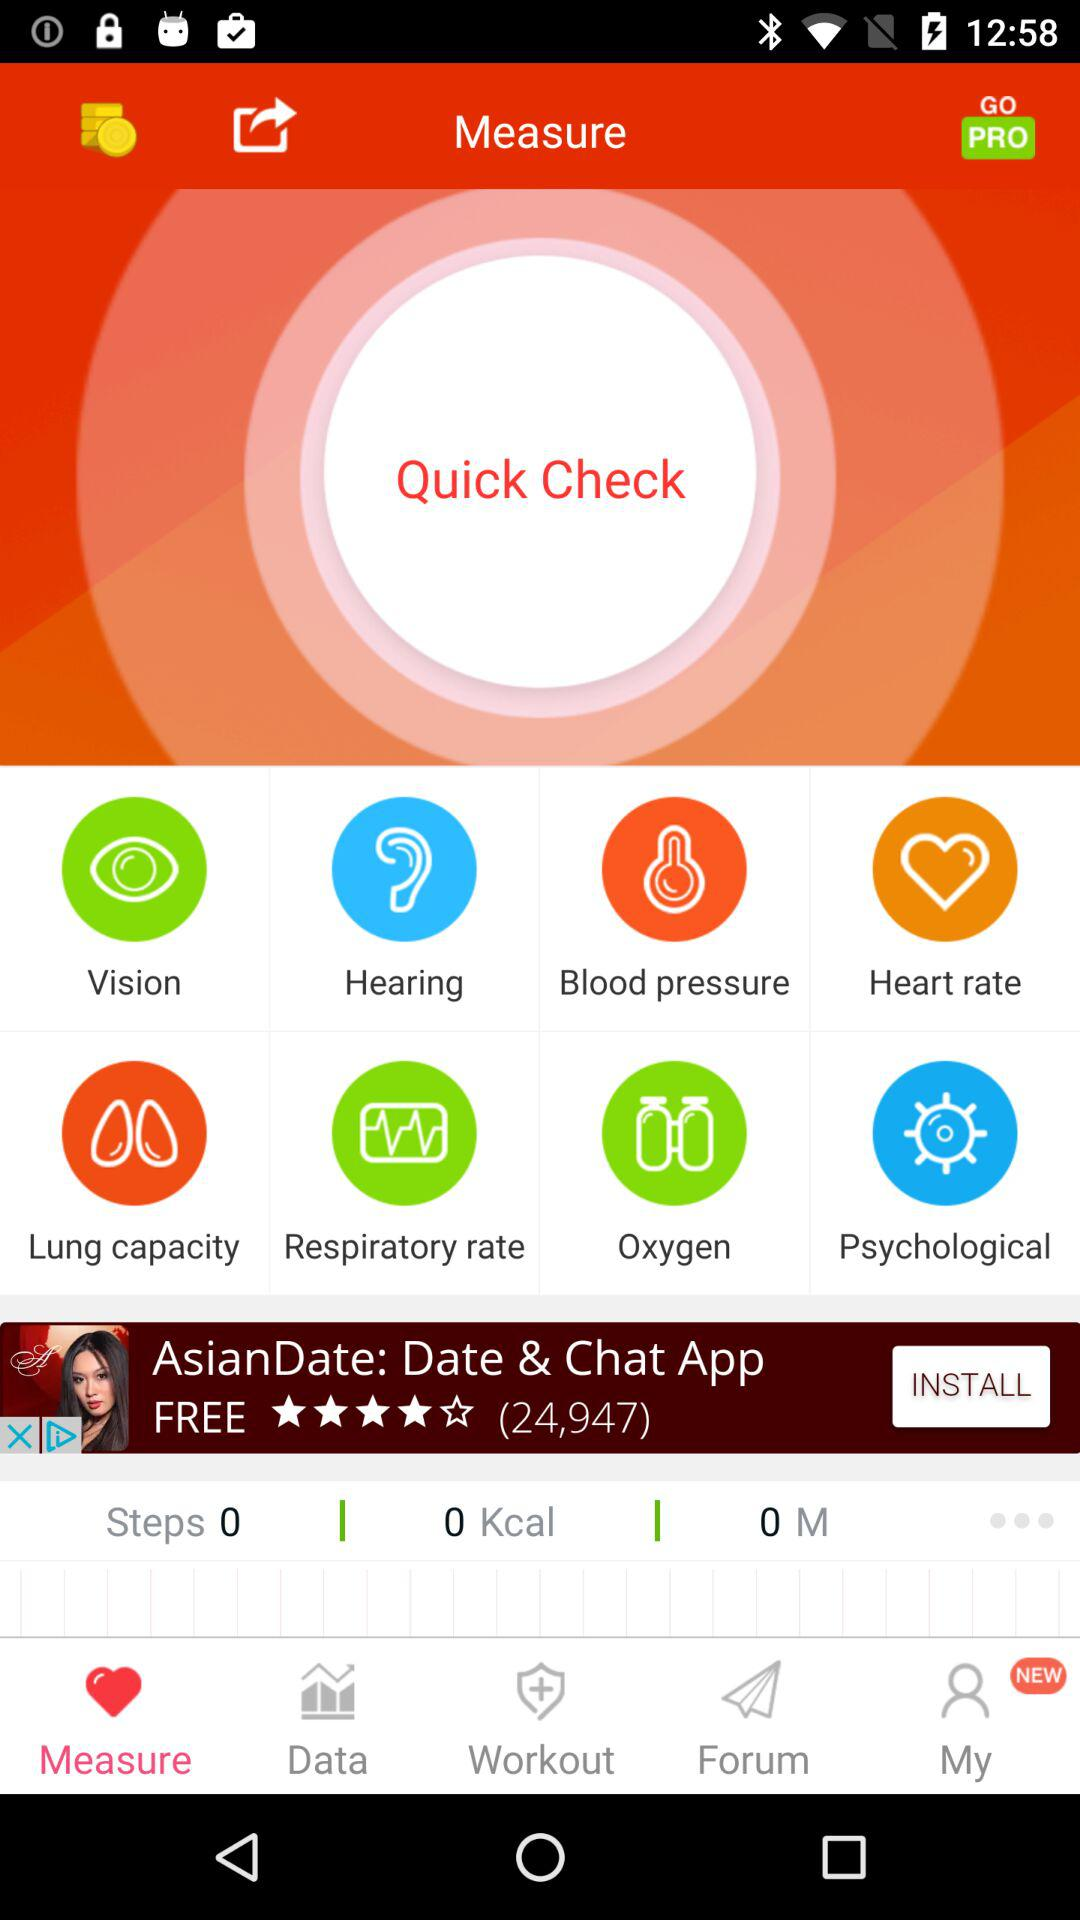How many calories are shown? There are zero calories. 